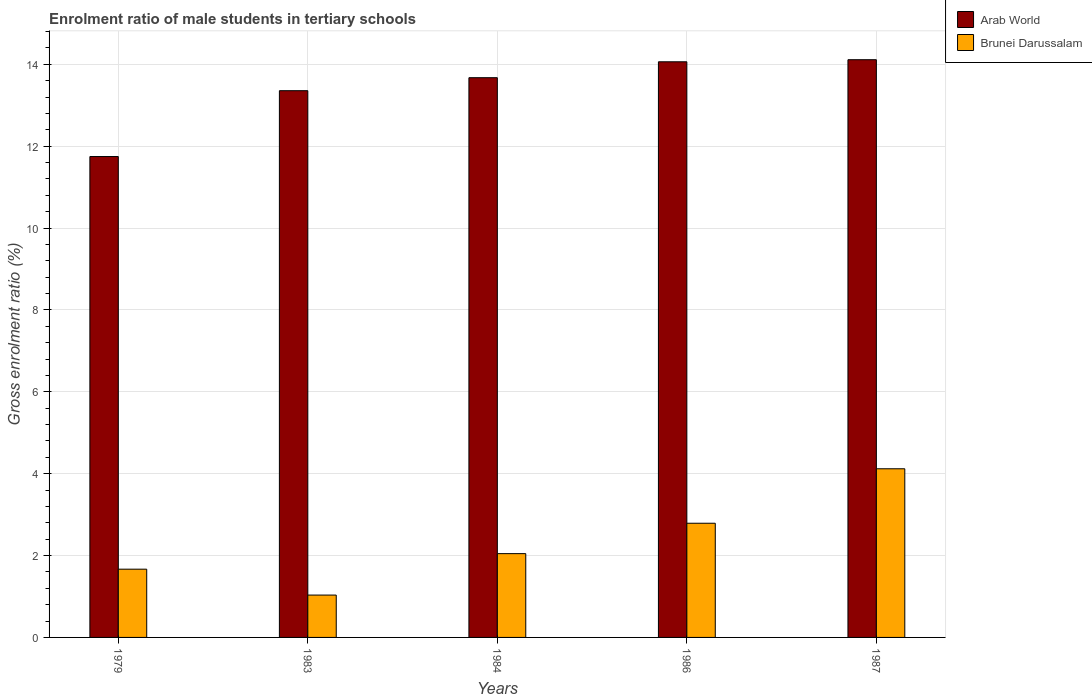Are the number of bars per tick equal to the number of legend labels?
Your answer should be compact. Yes. How many bars are there on the 5th tick from the left?
Give a very brief answer. 2. What is the enrolment ratio of male students in tertiary schools in Brunei Darussalam in 1979?
Provide a short and direct response. 1.67. Across all years, what is the maximum enrolment ratio of male students in tertiary schools in Arab World?
Offer a very short reply. 14.11. Across all years, what is the minimum enrolment ratio of male students in tertiary schools in Arab World?
Your answer should be compact. 11.75. In which year was the enrolment ratio of male students in tertiary schools in Arab World maximum?
Give a very brief answer. 1987. In which year was the enrolment ratio of male students in tertiary schools in Arab World minimum?
Offer a terse response. 1979. What is the total enrolment ratio of male students in tertiary schools in Brunei Darussalam in the graph?
Provide a succinct answer. 11.66. What is the difference between the enrolment ratio of male students in tertiary schools in Arab World in 1984 and that in 1986?
Your answer should be very brief. -0.39. What is the difference between the enrolment ratio of male students in tertiary schools in Arab World in 1987 and the enrolment ratio of male students in tertiary schools in Brunei Darussalam in 1983?
Offer a very short reply. 13.08. What is the average enrolment ratio of male students in tertiary schools in Brunei Darussalam per year?
Provide a succinct answer. 2.33. In the year 1984, what is the difference between the enrolment ratio of male students in tertiary schools in Arab World and enrolment ratio of male students in tertiary schools in Brunei Darussalam?
Offer a terse response. 11.63. What is the ratio of the enrolment ratio of male students in tertiary schools in Brunei Darussalam in 1983 to that in 1984?
Provide a succinct answer. 0.51. Is the enrolment ratio of male students in tertiary schools in Arab World in 1983 less than that in 1986?
Offer a very short reply. Yes. Is the difference between the enrolment ratio of male students in tertiary schools in Arab World in 1979 and 1986 greater than the difference between the enrolment ratio of male students in tertiary schools in Brunei Darussalam in 1979 and 1986?
Your answer should be very brief. No. What is the difference between the highest and the second highest enrolment ratio of male students in tertiary schools in Brunei Darussalam?
Give a very brief answer. 1.33. What is the difference between the highest and the lowest enrolment ratio of male students in tertiary schools in Brunei Darussalam?
Offer a very short reply. 3.09. What does the 2nd bar from the left in 1979 represents?
Provide a succinct answer. Brunei Darussalam. What does the 2nd bar from the right in 1987 represents?
Your response must be concise. Arab World. How many bars are there?
Your answer should be very brief. 10. What is the difference between two consecutive major ticks on the Y-axis?
Give a very brief answer. 2. Where does the legend appear in the graph?
Provide a succinct answer. Top right. How are the legend labels stacked?
Your answer should be compact. Vertical. What is the title of the graph?
Keep it short and to the point. Enrolment ratio of male students in tertiary schools. What is the label or title of the Y-axis?
Make the answer very short. Gross enrolment ratio (%). What is the Gross enrolment ratio (%) in Arab World in 1979?
Make the answer very short. 11.75. What is the Gross enrolment ratio (%) in Brunei Darussalam in 1979?
Offer a terse response. 1.67. What is the Gross enrolment ratio (%) in Arab World in 1983?
Make the answer very short. 13.36. What is the Gross enrolment ratio (%) in Brunei Darussalam in 1983?
Your response must be concise. 1.03. What is the Gross enrolment ratio (%) of Arab World in 1984?
Provide a succinct answer. 13.67. What is the Gross enrolment ratio (%) in Brunei Darussalam in 1984?
Give a very brief answer. 2.05. What is the Gross enrolment ratio (%) of Arab World in 1986?
Make the answer very short. 14.06. What is the Gross enrolment ratio (%) of Brunei Darussalam in 1986?
Provide a succinct answer. 2.79. What is the Gross enrolment ratio (%) in Arab World in 1987?
Make the answer very short. 14.11. What is the Gross enrolment ratio (%) of Brunei Darussalam in 1987?
Your answer should be very brief. 4.12. Across all years, what is the maximum Gross enrolment ratio (%) in Arab World?
Ensure brevity in your answer.  14.11. Across all years, what is the maximum Gross enrolment ratio (%) of Brunei Darussalam?
Give a very brief answer. 4.12. Across all years, what is the minimum Gross enrolment ratio (%) of Arab World?
Your answer should be very brief. 11.75. Across all years, what is the minimum Gross enrolment ratio (%) in Brunei Darussalam?
Give a very brief answer. 1.03. What is the total Gross enrolment ratio (%) of Arab World in the graph?
Your answer should be very brief. 66.95. What is the total Gross enrolment ratio (%) of Brunei Darussalam in the graph?
Provide a succinct answer. 11.66. What is the difference between the Gross enrolment ratio (%) in Arab World in 1979 and that in 1983?
Make the answer very short. -1.61. What is the difference between the Gross enrolment ratio (%) of Brunei Darussalam in 1979 and that in 1983?
Provide a short and direct response. 0.63. What is the difference between the Gross enrolment ratio (%) of Arab World in 1979 and that in 1984?
Provide a short and direct response. -1.93. What is the difference between the Gross enrolment ratio (%) of Brunei Darussalam in 1979 and that in 1984?
Your answer should be very brief. -0.38. What is the difference between the Gross enrolment ratio (%) in Arab World in 1979 and that in 1986?
Your response must be concise. -2.31. What is the difference between the Gross enrolment ratio (%) of Brunei Darussalam in 1979 and that in 1986?
Give a very brief answer. -1.12. What is the difference between the Gross enrolment ratio (%) in Arab World in 1979 and that in 1987?
Your answer should be compact. -2.37. What is the difference between the Gross enrolment ratio (%) of Brunei Darussalam in 1979 and that in 1987?
Offer a terse response. -2.45. What is the difference between the Gross enrolment ratio (%) in Arab World in 1983 and that in 1984?
Keep it short and to the point. -0.32. What is the difference between the Gross enrolment ratio (%) of Brunei Darussalam in 1983 and that in 1984?
Offer a very short reply. -1.01. What is the difference between the Gross enrolment ratio (%) in Arab World in 1983 and that in 1986?
Your response must be concise. -0.71. What is the difference between the Gross enrolment ratio (%) of Brunei Darussalam in 1983 and that in 1986?
Provide a succinct answer. -1.75. What is the difference between the Gross enrolment ratio (%) of Arab World in 1983 and that in 1987?
Your answer should be very brief. -0.76. What is the difference between the Gross enrolment ratio (%) in Brunei Darussalam in 1983 and that in 1987?
Your answer should be very brief. -3.09. What is the difference between the Gross enrolment ratio (%) in Arab World in 1984 and that in 1986?
Your answer should be very brief. -0.39. What is the difference between the Gross enrolment ratio (%) in Brunei Darussalam in 1984 and that in 1986?
Your answer should be very brief. -0.74. What is the difference between the Gross enrolment ratio (%) in Arab World in 1984 and that in 1987?
Provide a succinct answer. -0.44. What is the difference between the Gross enrolment ratio (%) of Brunei Darussalam in 1984 and that in 1987?
Ensure brevity in your answer.  -2.07. What is the difference between the Gross enrolment ratio (%) in Arab World in 1986 and that in 1987?
Make the answer very short. -0.05. What is the difference between the Gross enrolment ratio (%) of Brunei Darussalam in 1986 and that in 1987?
Your answer should be compact. -1.33. What is the difference between the Gross enrolment ratio (%) in Arab World in 1979 and the Gross enrolment ratio (%) in Brunei Darussalam in 1983?
Keep it short and to the point. 10.71. What is the difference between the Gross enrolment ratio (%) of Arab World in 1979 and the Gross enrolment ratio (%) of Brunei Darussalam in 1984?
Keep it short and to the point. 9.7. What is the difference between the Gross enrolment ratio (%) of Arab World in 1979 and the Gross enrolment ratio (%) of Brunei Darussalam in 1986?
Provide a short and direct response. 8.96. What is the difference between the Gross enrolment ratio (%) of Arab World in 1979 and the Gross enrolment ratio (%) of Brunei Darussalam in 1987?
Your answer should be compact. 7.63. What is the difference between the Gross enrolment ratio (%) in Arab World in 1983 and the Gross enrolment ratio (%) in Brunei Darussalam in 1984?
Give a very brief answer. 11.31. What is the difference between the Gross enrolment ratio (%) in Arab World in 1983 and the Gross enrolment ratio (%) in Brunei Darussalam in 1986?
Offer a terse response. 10.57. What is the difference between the Gross enrolment ratio (%) of Arab World in 1983 and the Gross enrolment ratio (%) of Brunei Darussalam in 1987?
Offer a very short reply. 9.24. What is the difference between the Gross enrolment ratio (%) in Arab World in 1984 and the Gross enrolment ratio (%) in Brunei Darussalam in 1986?
Offer a terse response. 10.88. What is the difference between the Gross enrolment ratio (%) of Arab World in 1984 and the Gross enrolment ratio (%) of Brunei Darussalam in 1987?
Ensure brevity in your answer.  9.55. What is the difference between the Gross enrolment ratio (%) in Arab World in 1986 and the Gross enrolment ratio (%) in Brunei Darussalam in 1987?
Ensure brevity in your answer.  9.94. What is the average Gross enrolment ratio (%) of Arab World per year?
Offer a terse response. 13.39. What is the average Gross enrolment ratio (%) in Brunei Darussalam per year?
Your response must be concise. 2.33. In the year 1979, what is the difference between the Gross enrolment ratio (%) in Arab World and Gross enrolment ratio (%) in Brunei Darussalam?
Your response must be concise. 10.08. In the year 1983, what is the difference between the Gross enrolment ratio (%) in Arab World and Gross enrolment ratio (%) in Brunei Darussalam?
Your response must be concise. 12.32. In the year 1984, what is the difference between the Gross enrolment ratio (%) of Arab World and Gross enrolment ratio (%) of Brunei Darussalam?
Give a very brief answer. 11.63. In the year 1986, what is the difference between the Gross enrolment ratio (%) of Arab World and Gross enrolment ratio (%) of Brunei Darussalam?
Your answer should be compact. 11.27. In the year 1987, what is the difference between the Gross enrolment ratio (%) in Arab World and Gross enrolment ratio (%) in Brunei Darussalam?
Your response must be concise. 9.99. What is the ratio of the Gross enrolment ratio (%) of Arab World in 1979 to that in 1983?
Offer a terse response. 0.88. What is the ratio of the Gross enrolment ratio (%) in Brunei Darussalam in 1979 to that in 1983?
Provide a succinct answer. 1.61. What is the ratio of the Gross enrolment ratio (%) in Arab World in 1979 to that in 1984?
Provide a succinct answer. 0.86. What is the ratio of the Gross enrolment ratio (%) in Brunei Darussalam in 1979 to that in 1984?
Provide a succinct answer. 0.81. What is the ratio of the Gross enrolment ratio (%) in Arab World in 1979 to that in 1986?
Your answer should be very brief. 0.84. What is the ratio of the Gross enrolment ratio (%) in Brunei Darussalam in 1979 to that in 1986?
Your answer should be compact. 0.6. What is the ratio of the Gross enrolment ratio (%) of Arab World in 1979 to that in 1987?
Provide a succinct answer. 0.83. What is the ratio of the Gross enrolment ratio (%) in Brunei Darussalam in 1979 to that in 1987?
Give a very brief answer. 0.4. What is the ratio of the Gross enrolment ratio (%) of Arab World in 1983 to that in 1984?
Your answer should be compact. 0.98. What is the ratio of the Gross enrolment ratio (%) in Brunei Darussalam in 1983 to that in 1984?
Provide a short and direct response. 0.51. What is the ratio of the Gross enrolment ratio (%) in Arab World in 1983 to that in 1986?
Keep it short and to the point. 0.95. What is the ratio of the Gross enrolment ratio (%) of Brunei Darussalam in 1983 to that in 1986?
Your answer should be very brief. 0.37. What is the ratio of the Gross enrolment ratio (%) of Arab World in 1983 to that in 1987?
Make the answer very short. 0.95. What is the ratio of the Gross enrolment ratio (%) of Brunei Darussalam in 1983 to that in 1987?
Your answer should be compact. 0.25. What is the ratio of the Gross enrolment ratio (%) in Arab World in 1984 to that in 1986?
Provide a short and direct response. 0.97. What is the ratio of the Gross enrolment ratio (%) in Brunei Darussalam in 1984 to that in 1986?
Provide a succinct answer. 0.73. What is the ratio of the Gross enrolment ratio (%) of Arab World in 1984 to that in 1987?
Offer a very short reply. 0.97. What is the ratio of the Gross enrolment ratio (%) in Brunei Darussalam in 1984 to that in 1987?
Make the answer very short. 0.5. What is the ratio of the Gross enrolment ratio (%) of Arab World in 1986 to that in 1987?
Offer a very short reply. 1. What is the ratio of the Gross enrolment ratio (%) of Brunei Darussalam in 1986 to that in 1987?
Give a very brief answer. 0.68. What is the difference between the highest and the second highest Gross enrolment ratio (%) of Arab World?
Offer a very short reply. 0.05. What is the difference between the highest and the second highest Gross enrolment ratio (%) of Brunei Darussalam?
Your answer should be compact. 1.33. What is the difference between the highest and the lowest Gross enrolment ratio (%) of Arab World?
Give a very brief answer. 2.37. What is the difference between the highest and the lowest Gross enrolment ratio (%) of Brunei Darussalam?
Your answer should be compact. 3.09. 